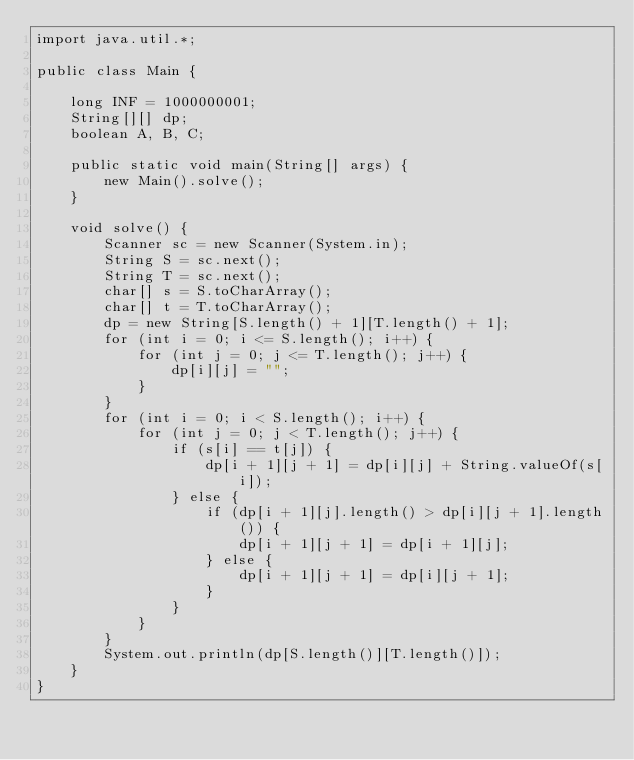Convert code to text. <code><loc_0><loc_0><loc_500><loc_500><_Java_>import java.util.*;

public class Main {

    long INF = 1000000001;
    String[][] dp;
    boolean A, B, C;

    public static void main(String[] args) {
        new Main().solve();
    }

    void solve() {
        Scanner sc = new Scanner(System.in);
        String S = sc.next();
        String T = sc.next();
        char[] s = S.toCharArray();
        char[] t = T.toCharArray();
        dp = new String[S.length() + 1][T.length() + 1];
        for (int i = 0; i <= S.length(); i++) {
            for (int j = 0; j <= T.length(); j++) {
                dp[i][j] = "";
            }
        }
        for (int i = 0; i < S.length(); i++) {
            for (int j = 0; j < T.length(); j++) {
                if (s[i] == t[j]) {
                    dp[i + 1][j + 1] = dp[i][j] + String.valueOf(s[i]);
                } else {
                    if (dp[i + 1][j].length() > dp[i][j + 1].length()) {
                        dp[i + 1][j + 1] = dp[i + 1][j];
                    } else {
                        dp[i + 1][j + 1] = dp[i][j + 1];
                    }
                }
            }
        }
        System.out.println(dp[S.length()][T.length()]);
    }
}</code> 